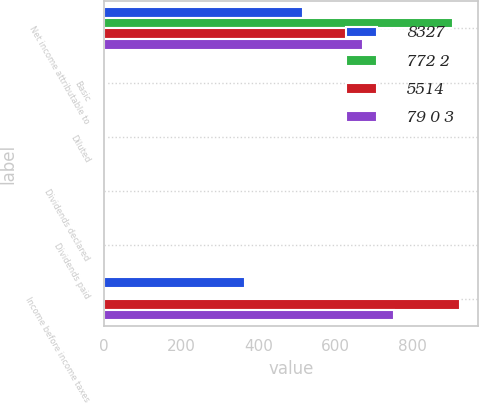Convert chart to OTSL. <chart><loc_0><loc_0><loc_500><loc_500><stacked_bar_chart><ecel><fcel>Net income attributable to<fcel>Basic<fcel>Diluted<fcel>Dividends declared<fcel>Dividends paid<fcel>Income before income taxes<nl><fcel>8327<fcel>514<fcel>1.22<fcel>1.2<fcel>0.35<fcel>0.3<fcel>364<nl><fcel>772 2<fcel>904<fcel>2.15<fcel>2.12<fcel>0.35<fcel>0.35<fcel>1.63<nl><fcel>5514<fcel>712<fcel>1.71<fcel>1.69<fcel>0.41<fcel>0.35<fcel>922<nl><fcel>79 0 3<fcel>670<fcel>1.63<fcel>1.62<fcel>0.41<fcel>0.41<fcel>750<nl></chart> 